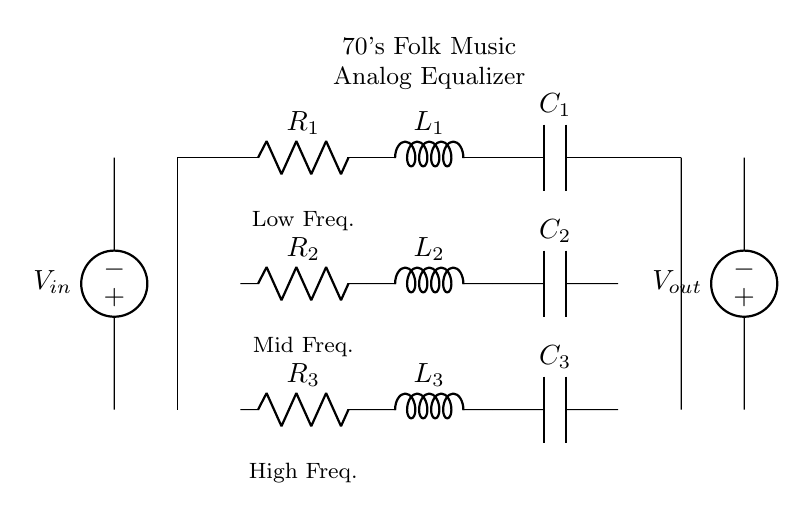What is the voltage source in this circuit? The circuit has two voltage sources, designated as V_in on the left and V_out on the right, providing input and output voltages respectively.
Answer: V_in, V_out What are the components connected to the first input resistor? The first input resistor, R_1, is connected to an inductor L_1 followed by a capacitor C_1 in series. These components form a filter to affect the audio frequencies.
Answer: L_1, C_1 How many distinct frequency filters are there? The circuit clearly shows three sets of RLC components organized to process audio: one each for low, mid, and high frequencies. This delineation indicates three distinct filters.
Answer: 3 What type of connections are made between the resistors, inductors, and capacitors? All components (resistors, inductors, and capacitors) are connected in series within each filter section, forming a series RLC circuit, and connecting each section in parallel for overall functionality.
Answer: Series Which frequency is represented by R_2, L_2, and C_2? The components R_2, L_2, and C_2 are specifically designated for the mid-frequencies, as noted in the diagram's labeling indicating their function in the equalizer.
Answer: Mid Frequency How does the circuit affect the sound frequencies? The RLC filters shape frequency response by selectively allowing certain frequencies to pass while attenuating others, enhancing the sound quality characteristic of the 70's folk music genre.
Answer: Enhances sound quality What happens if the capacitance of C_3 increases? Increasing C_3 will lower the cutoff frequency of the corresponding high-frequency filter. This means more of the high frequencies will pass through, changing the overall tonal balance of the audio output.
Answer: Lower cutoff frequency 